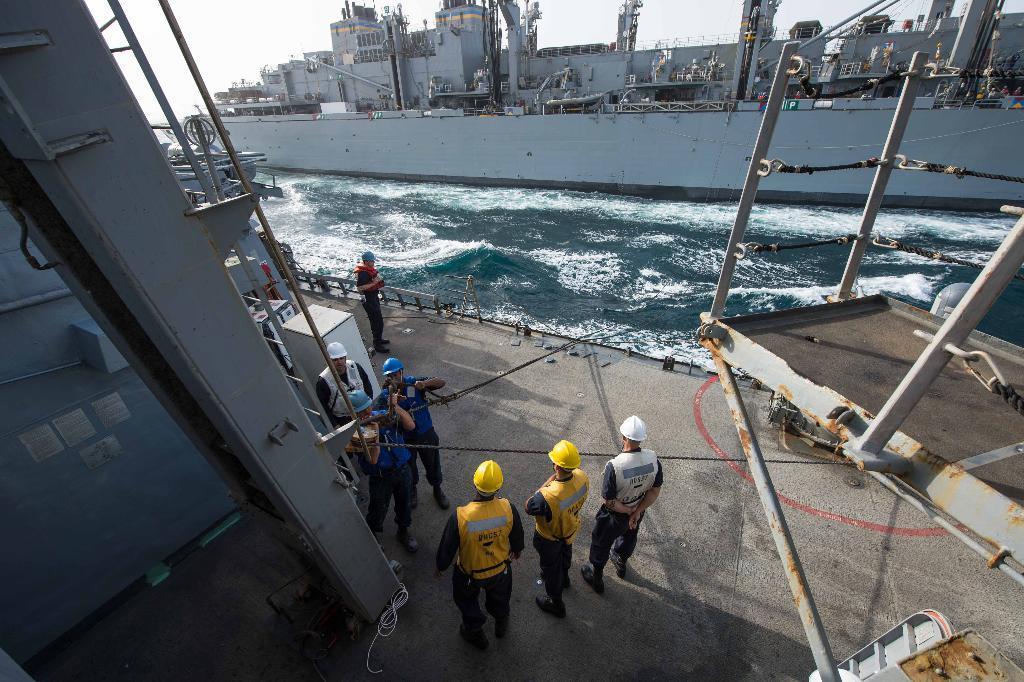In one or two sentences, can you explain what this image depicts? There are persons in blue color t-shirts working and standing on the floor near other persons who are standing on the floor. In the background, there is water on which, there is a ship and there is sky. 